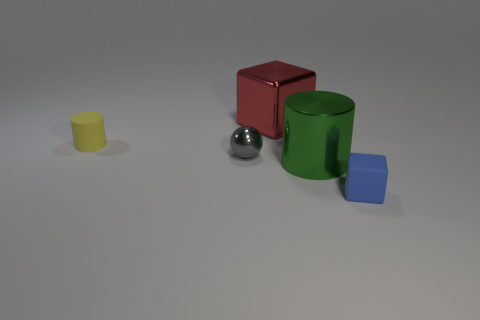The other object that is the same shape as the blue object is what color?
Keep it short and to the point. Red. What shape is the thing that is in front of the ball and behind the blue rubber block?
Provide a succinct answer. Cylinder. The tiny thing that is both in front of the yellow matte cylinder and left of the tiny blue rubber cube is what color?
Your answer should be compact. Gray. Are there more things left of the yellow cylinder than tiny yellow matte cylinders that are to the right of the large red object?
Offer a terse response. No. There is a large shiny object in front of the gray object; what color is it?
Provide a short and direct response. Green. Do the small matte object behind the blue cube and the small matte thing to the right of the large red shiny thing have the same shape?
Ensure brevity in your answer.  No. Is there a gray matte ball of the same size as the gray metal sphere?
Your answer should be very brief. No. There is a cylinder in front of the matte cylinder; what material is it?
Your response must be concise. Metal. Does the block in front of the shiny cylinder have the same material as the yellow cylinder?
Your answer should be very brief. Yes. Are there any yellow cylinders?
Keep it short and to the point. Yes. 